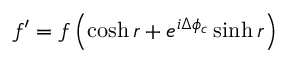Convert formula to latex. <formula><loc_0><loc_0><loc_500><loc_500>f ^ { \prime } = f \left ( \cosh r + e ^ { i \Delta \phi _ { c } } \sinh r \right )</formula> 